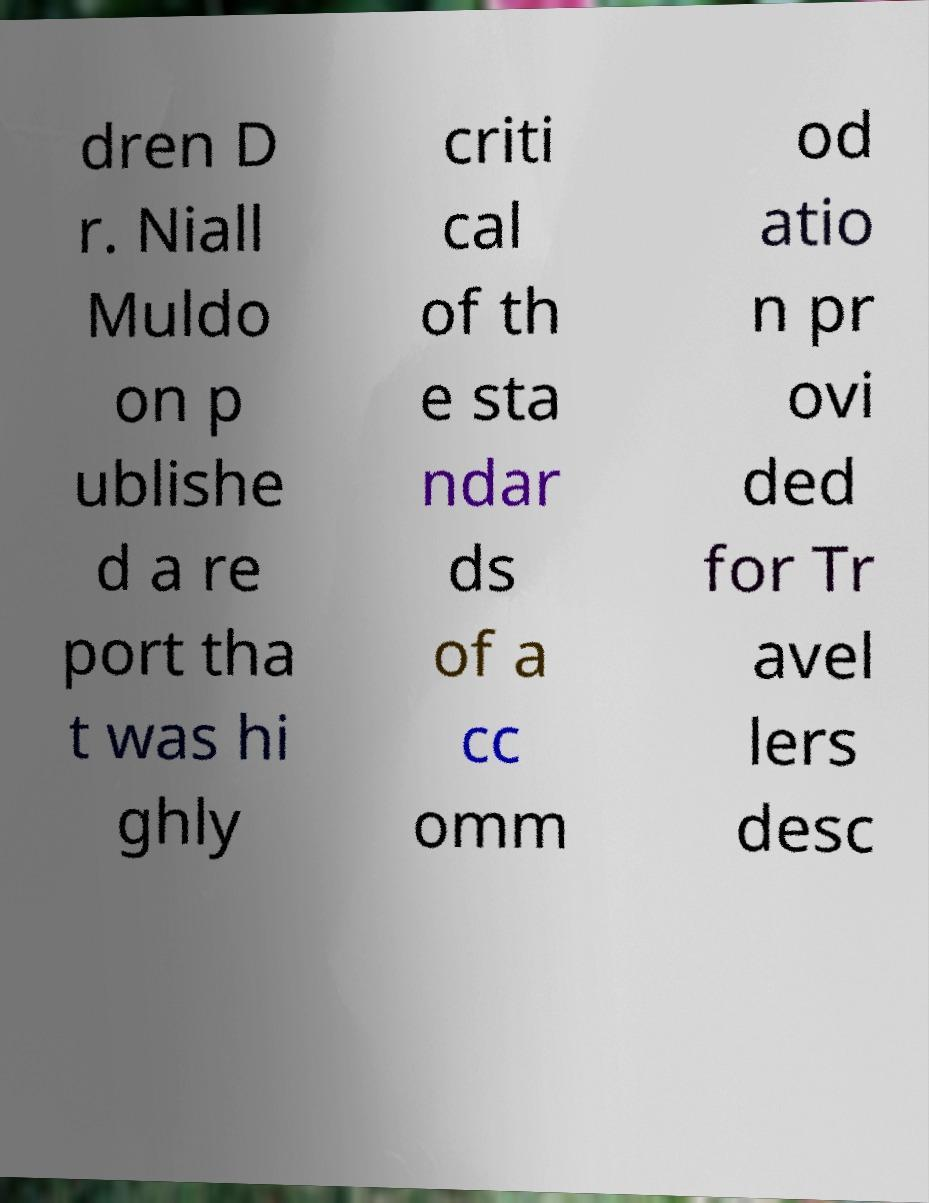What messages or text are displayed in this image? I need them in a readable, typed format. dren D r. Niall Muldo on p ublishe d a re port tha t was hi ghly criti cal of th e sta ndar ds of a cc omm od atio n pr ovi ded for Tr avel lers desc 